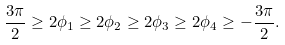<formula> <loc_0><loc_0><loc_500><loc_500>\frac { 3 \pi } { 2 } \geq 2 \phi _ { 1 } \geq 2 \phi _ { 2 } \geq 2 \phi _ { 3 } \geq 2 \phi _ { 4 } \geq - \frac { 3 \pi } { 2 } .</formula> 